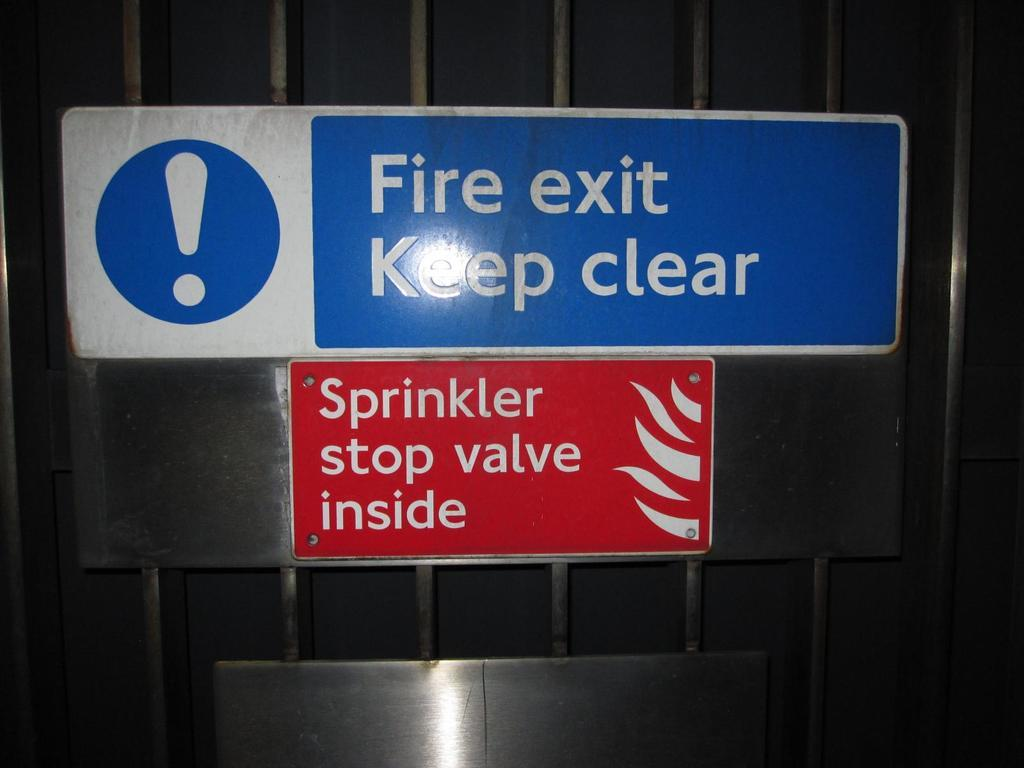<image>
Render a clear and concise summary of the photo. A blue sign says Fire exit keep clear and sprinkler stop valve inside. 